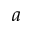<formula> <loc_0><loc_0><loc_500><loc_500>a</formula> 